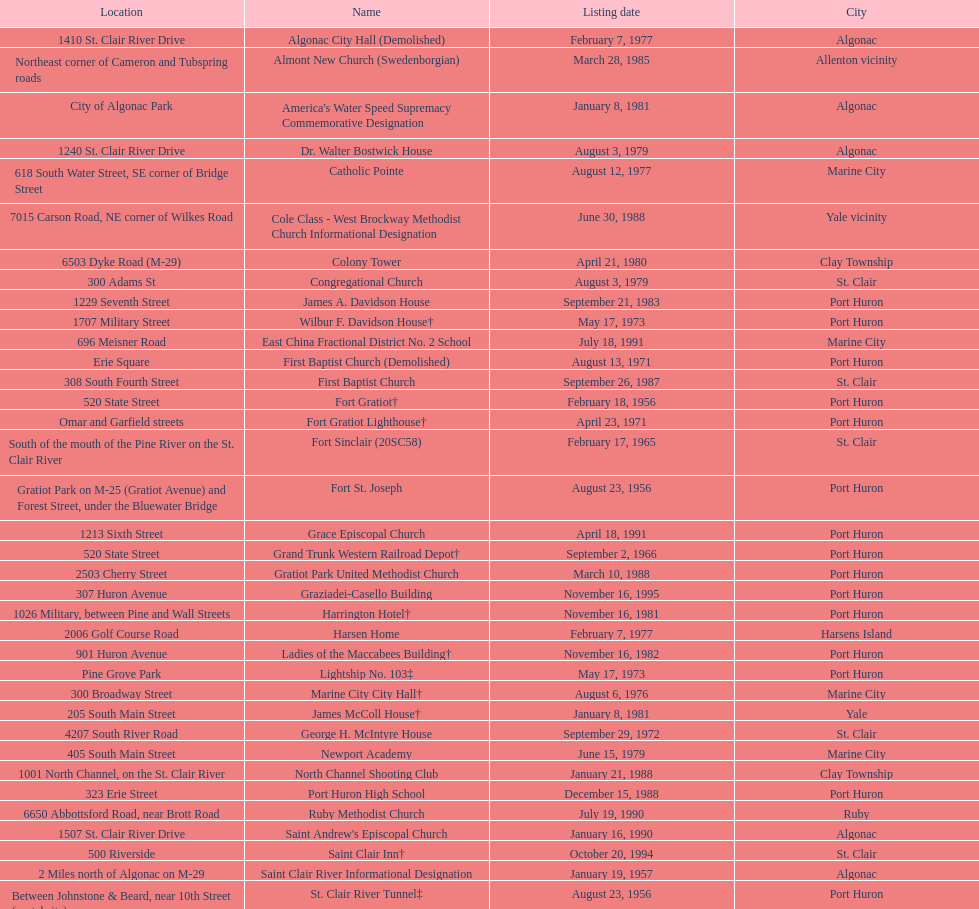Fort gratiot lighthouse and fort st. joseph are located in what city? Port Huron. 